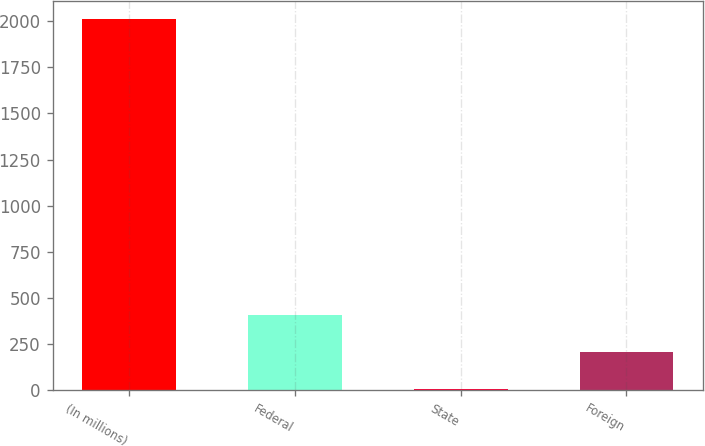<chart> <loc_0><loc_0><loc_500><loc_500><bar_chart><fcel>(In millions)<fcel>Federal<fcel>State<fcel>Foreign<nl><fcel>2009<fcel>407.4<fcel>7<fcel>207.2<nl></chart> 